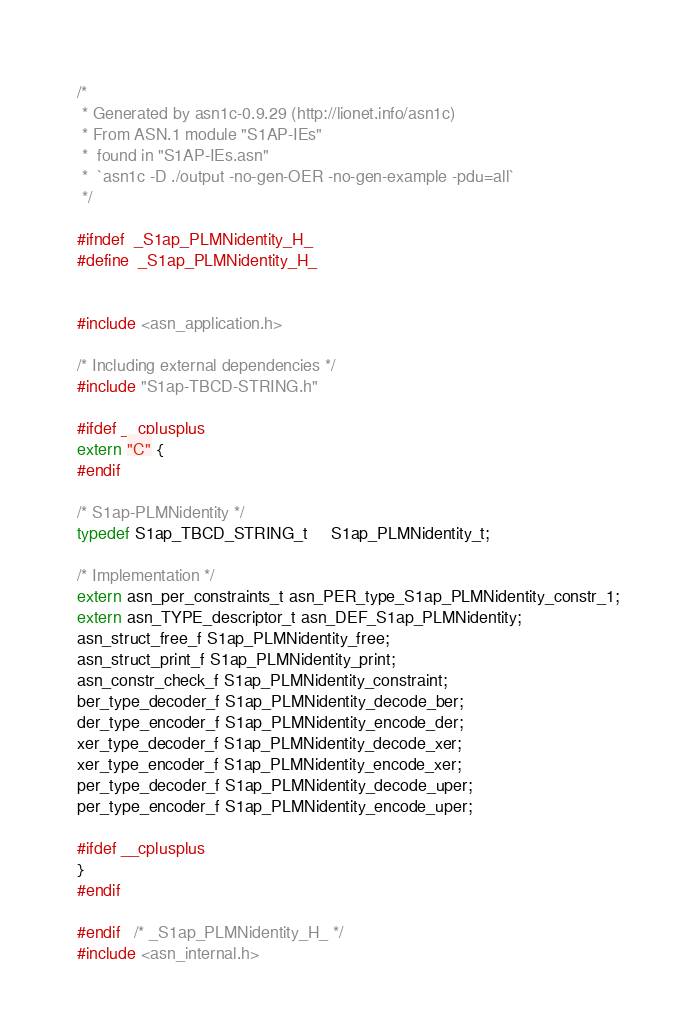<code> <loc_0><loc_0><loc_500><loc_500><_C_>/*
 * Generated by asn1c-0.9.29 (http://lionet.info/asn1c)
 * From ASN.1 module "S1AP-IEs"
 * 	found in "S1AP-IEs.asn"
 * 	`asn1c -D ./output -no-gen-OER -no-gen-example -pdu=all`
 */

#ifndef	_S1ap_PLMNidentity_H_
#define	_S1ap_PLMNidentity_H_


#include <asn_application.h>

/* Including external dependencies */
#include "S1ap-TBCD-STRING.h"

#ifdef __cplusplus
extern "C" {
#endif

/* S1ap-PLMNidentity */
typedef S1ap_TBCD_STRING_t	 S1ap_PLMNidentity_t;

/* Implementation */
extern asn_per_constraints_t asn_PER_type_S1ap_PLMNidentity_constr_1;
extern asn_TYPE_descriptor_t asn_DEF_S1ap_PLMNidentity;
asn_struct_free_f S1ap_PLMNidentity_free;
asn_struct_print_f S1ap_PLMNidentity_print;
asn_constr_check_f S1ap_PLMNidentity_constraint;
ber_type_decoder_f S1ap_PLMNidentity_decode_ber;
der_type_encoder_f S1ap_PLMNidentity_encode_der;
xer_type_decoder_f S1ap_PLMNidentity_decode_xer;
xer_type_encoder_f S1ap_PLMNidentity_encode_xer;
per_type_decoder_f S1ap_PLMNidentity_decode_uper;
per_type_encoder_f S1ap_PLMNidentity_encode_uper;

#ifdef __cplusplus
}
#endif

#endif	/* _S1ap_PLMNidentity_H_ */
#include <asn_internal.h>
</code> 